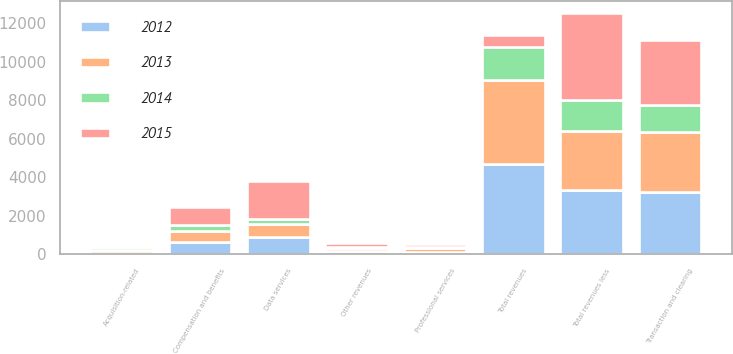<chart> <loc_0><loc_0><loc_500><loc_500><stacked_bar_chart><ecel><fcel>Transaction and clearing<fcel>Data services<fcel>Other revenues<fcel>Total revenues<fcel>Total revenues less<fcel>Compensation and benefits<fcel>Professional services<fcel>Acquisition-related<nl><fcel>2015<fcel>3384<fcel>1978<fcel>177<fcel>611<fcel>4499<fcel>945<fcel>137<fcel>80<nl><fcel>2012<fcel>3228<fcel>871<fcel>178<fcel>4682<fcel>3338<fcel>611<fcel>139<fcel>88<nl><fcel>2013<fcel>3144<fcel>691<fcel>150<fcel>4352<fcel>3092<fcel>592<fcel>181<fcel>129<nl><fcel>2014<fcel>1393<fcel>246<fcel>58<fcel>1730<fcel>1598<fcel>302<fcel>54<fcel>143<nl></chart> 